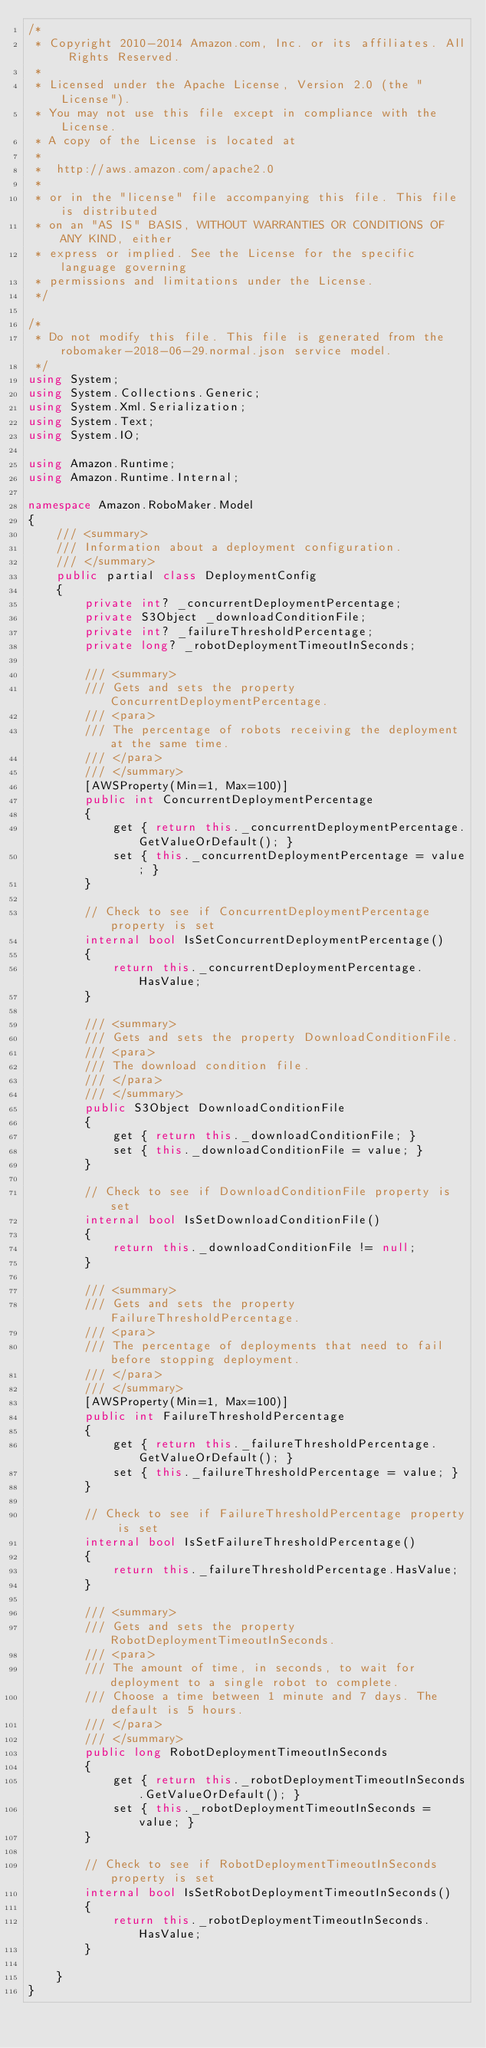Convert code to text. <code><loc_0><loc_0><loc_500><loc_500><_C#_>/*
 * Copyright 2010-2014 Amazon.com, Inc. or its affiliates. All Rights Reserved.
 * 
 * Licensed under the Apache License, Version 2.0 (the "License").
 * You may not use this file except in compliance with the License.
 * A copy of the License is located at
 * 
 *  http://aws.amazon.com/apache2.0
 * 
 * or in the "license" file accompanying this file. This file is distributed
 * on an "AS IS" BASIS, WITHOUT WARRANTIES OR CONDITIONS OF ANY KIND, either
 * express or implied. See the License for the specific language governing
 * permissions and limitations under the License.
 */

/*
 * Do not modify this file. This file is generated from the robomaker-2018-06-29.normal.json service model.
 */
using System;
using System.Collections.Generic;
using System.Xml.Serialization;
using System.Text;
using System.IO;

using Amazon.Runtime;
using Amazon.Runtime.Internal;

namespace Amazon.RoboMaker.Model
{
    /// <summary>
    /// Information about a deployment configuration.
    /// </summary>
    public partial class DeploymentConfig
    {
        private int? _concurrentDeploymentPercentage;
        private S3Object _downloadConditionFile;
        private int? _failureThresholdPercentage;
        private long? _robotDeploymentTimeoutInSeconds;

        /// <summary>
        /// Gets and sets the property ConcurrentDeploymentPercentage. 
        /// <para>
        /// The percentage of robots receiving the deployment at the same time.
        /// </para>
        /// </summary>
        [AWSProperty(Min=1, Max=100)]
        public int ConcurrentDeploymentPercentage
        {
            get { return this._concurrentDeploymentPercentage.GetValueOrDefault(); }
            set { this._concurrentDeploymentPercentage = value; }
        }

        // Check to see if ConcurrentDeploymentPercentage property is set
        internal bool IsSetConcurrentDeploymentPercentage()
        {
            return this._concurrentDeploymentPercentage.HasValue; 
        }

        /// <summary>
        /// Gets and sets the property DownloadConditionFile. 
        /// <para>
        /// The download condition file.
        /// </para>
        /// </summary>
        public S3Object DownloadConditionFile
        {
            get { return this._downloadConditionFile; }
            set { this._downloadConditionFile = value; }
        }

        // Check to see if DownloadConditionFile property is set
        internal bool IsSetDownloadConditionFile()
        {
            return this._downloadConditionFile != null;
        }

        /// <summary>
        /// Gets and sets the property FailureThresholdPercentage. 
        /// <para>
        /// The percentage of deployments that need to fail before stopping deployment.
        /// </para>
        /// </summary>
        [AWSProperty(Min=1, Max=100)]
        public int FailureThresholdPercentage
        {
            get { return this._failureThresholdPercentage.GetValueOrDefault(); }
            set { this._failureThresholdPercentage = value; }
        }

        // Check to see if FailureThresholdPercentage property is set
        internal bool IsSetFailureThresholdPercentage()
        {
            return this._failureThresholdPercentage.HasValue; 
        }

        /// <summary>
        /// Gets and sets the property RobotDeploymentTimeoutInSeconds. 
        /// <para>
        /// The amount of time, in seconds, to wait for deployment to a single robot to complete.
        /// Choose a time between 1 minute and 7 days. The default is 5 hours.
        /// </para>
        /// </summary>
        public long RobotDeploymentTimeoutInSeconds
        {
            get { return this._robotDeploymentTimeoutInSeconds.GetValueOrDefault(); }
            set { this._robotDeploymentTimeoutInSeconds = value; }
        }

        // Check to see if RobotDeploymentTimeoutInSeconds property is set
        internal bool IsSetRobotDeploymentTimeoutInSeconds()
        {
            return this._robotDeploymentTimeoutInSeconds.HasValue; 
        }

    }
}</code> 